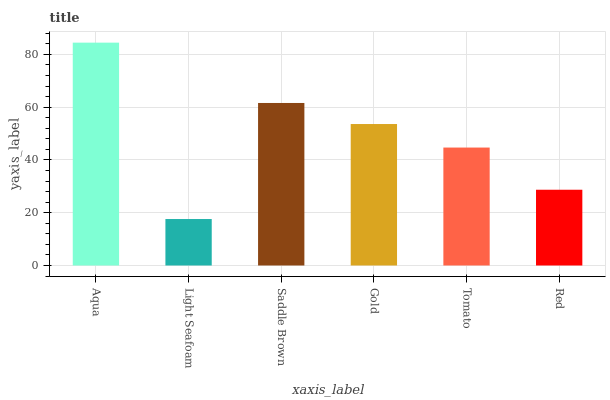Is Light Seafoam the minimum?
Answer yes or no. Yes. Is Aqua the maximum?
Answer yes or no. Yes. Is Saddle Brown the minimum?
Answer yes or no. No. Is Saddle Brown the maximum?
Answer yes or no. No. Is Saddle Brown greater than Light Seafoam?
Answer yes or no. Yes. Is Light Seafoam less than Saddle Brown?
Answer yes or no. Yes. Is Light Seafoam greater than Saddle Brown?
Answer yes or no. No. Is Saddle Brown less than Light Seafoam?
Answer yes or no. No. Is Gold the high median?
Answer yes or no. Yes. Is Tomato the low median?
Answer yes or no. Yes. Is Light Seafoam the high median?
Answer yes or no. No. Is Red the low median?
Answer yes or no. No. 